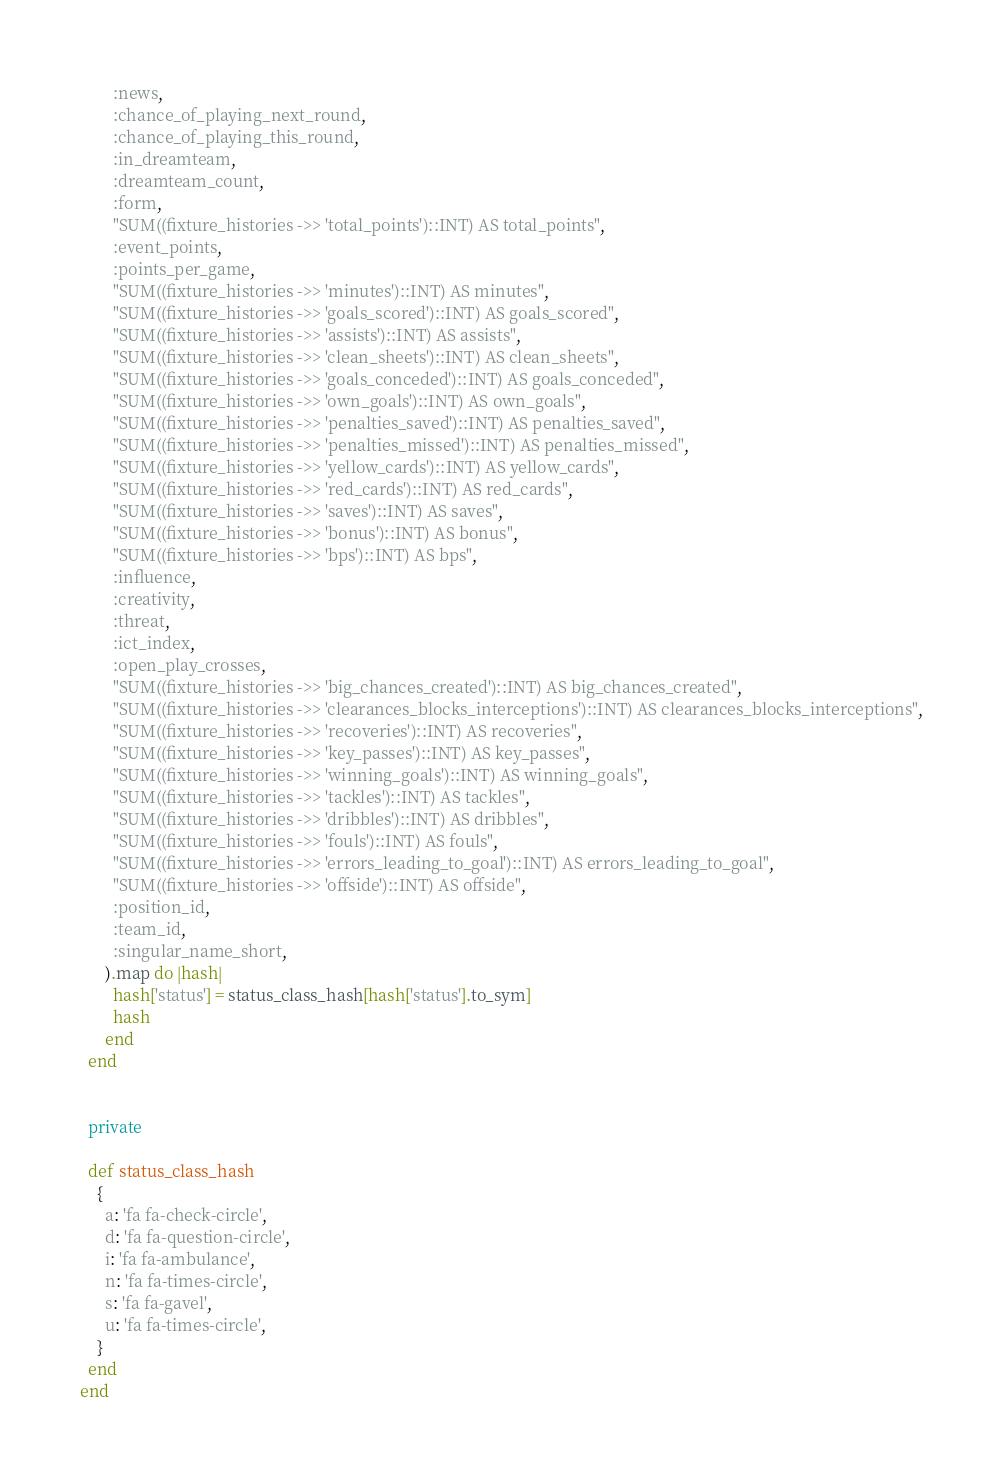<code> <loc_0><loc_0><loc_500><loc_500><_Ruby_>        :news,
        :chance_of_playing_next_round,
        :chance_of_playing_this_round,
        :in_dreamteam,
        :dreamteam_count,
        :form,
        "SUM((fixture_histories ->> 'total_points')::INT) AS total_points",
        :event_points,
        :points_per_game,
        "SUM((fixture_histories ->> 'minutes')::INT) AS minutes",
        "SUM((fixture_histories ->> 'goals_scored')::INT) AS goals_scored",
        "SUM((fixture_histories ->> 'assists')::INT) AS assists",
        "SUM((fixture_histories ->> 'clean_sheets')::INT) AS clean_sheets",
        "SUM((fixture_histories ->> 'goals_conceded')::INT) AS goals_conceded",
        "SUM((fixture_histories ->> 'own_goals')::INT) AS own_goals",
        "SUM((fixture_histories ->> 'penalties_saved')::INT) AS penalties_saved",
        "SUM((fixture_histories ->> 'penalties_missed')::INT) AS penalties_missed",
        "SUM((fixture_histories ->> 'yellow_cards')::INT) AS yellow_cards",
        "SUM((fixture_histories ->> 'red_cards')::INT) AS red_cards",
        "SUM((fixture_histories ->> 'saves')::INT) AS saves",
        "SUM((fixture_histories ->> 'bonus')::INT) AS bonus",
        "SUM((fixture_histories ->> 'bps')::INT) AS bps",
        :influence,
        :creativity,
        :threat,
        :ict_index,
        :open_play_crosses,
        "SUM((fixture_histories ->> 'big_chances_created')::INT) AS big_chances_created",
        "SUM((fixture_histories ->> 'clearances_blocks_interceptions')::INT) AS clearances_blocks_interceptions",
        "SUM((fixture_histories ->> 'recoveries')::INT) AS recoveries",
        "SUM((fixture_histories ->> 'key_passes')::INT) AS key_passes",
        "SUM((fixture_histories ->> 'winning_goals')::INT) AS winning_goals",
        "SUM((fixture_histories ->> 'tackles')::INT) AS tackles",
        "SUM((fixture_histories ->> 'dribbles')::INT) AS dribbles",
        "SUM((fixture_histories ->> 'fouls')::INT) AS fouls",
        "SUM((fixture_histories ->> 'errors_leading_to_goal')::INT) AS errors_leading_to_goal",
        "SUM((fixture_histories ->> 'offside')::INT) AS offside",
        :position_id,
        :team_id,
        :singular_name_short,
      ).map do |hash|
        hash['status'] = status_class_hash[hash['status'].to_sym]
        hash
      end
  end


  private

  def status_class_hash
    {
      a: 'fa fa-check-circle',
      d: 'fa fa-question-circle',
      i: 'fa fa-ambulance',
      n: 'fa fa-times-circle',
      s: 'fa fa-gavel',
      u: 'fa fa-times-circle',
    }
  end
end
</code> 